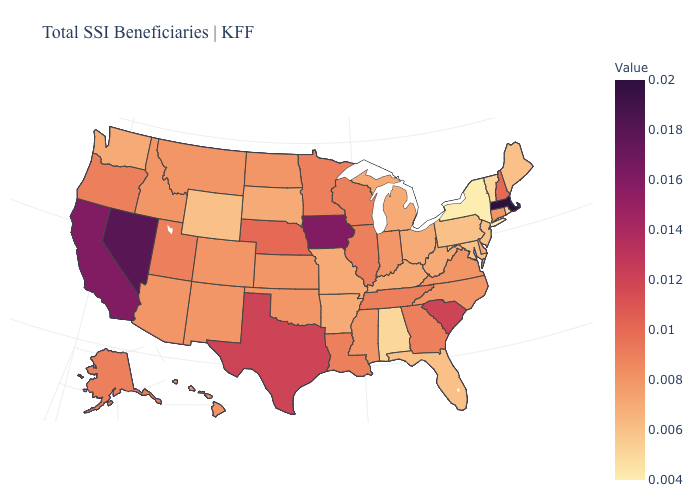Does New York have the lowest value in the USA?
Quick response, please. Yes. Does the map have missing data?
Write a very short answer. No. 